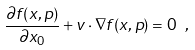Convert formula to latex. <formula><loc_0><loc_0><loc_500><loc_500>\frac { \partial f ( x , p ) } { \partial x _ { 0 } } + { v } \cdot \nabla f ( x , p ) = 0 \ ,</formula> 